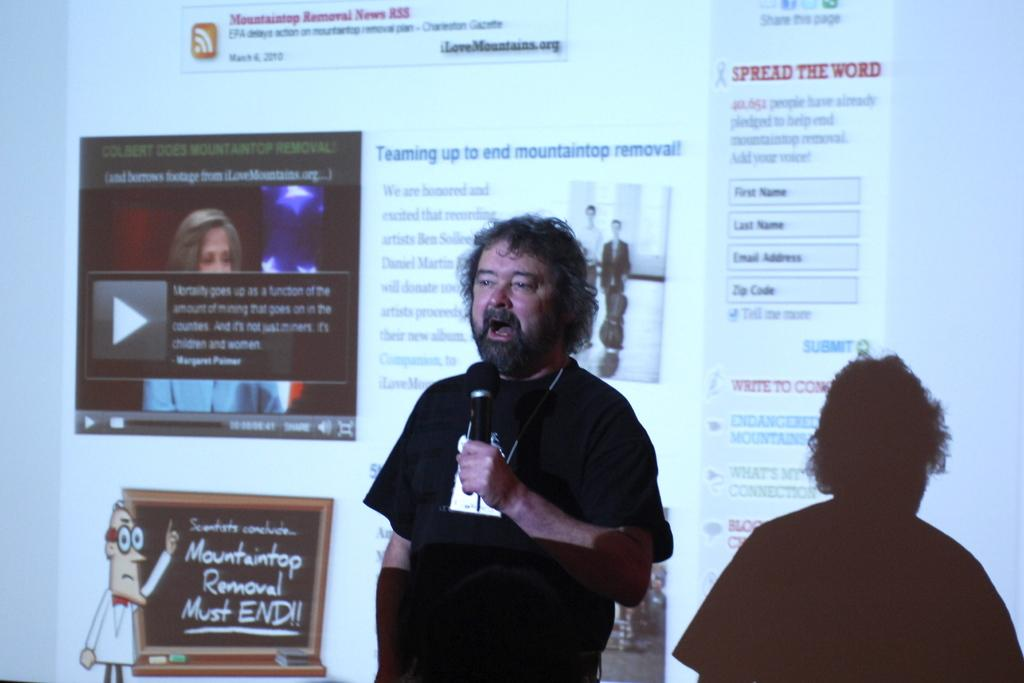What is the main subject of the image? There is a man in the image. What is the man doing in the image? The man is standing and speaking in the image. What tool is the man using to amplify his voice? The man is using a microphone in the image. What can be seen on the background of the image? There is a projector screen visible in the image. What type of shoe is the man wearing in the image? There is no information about the man's shoes in the image, so we cannot determine the type of shoe he is wearing. 